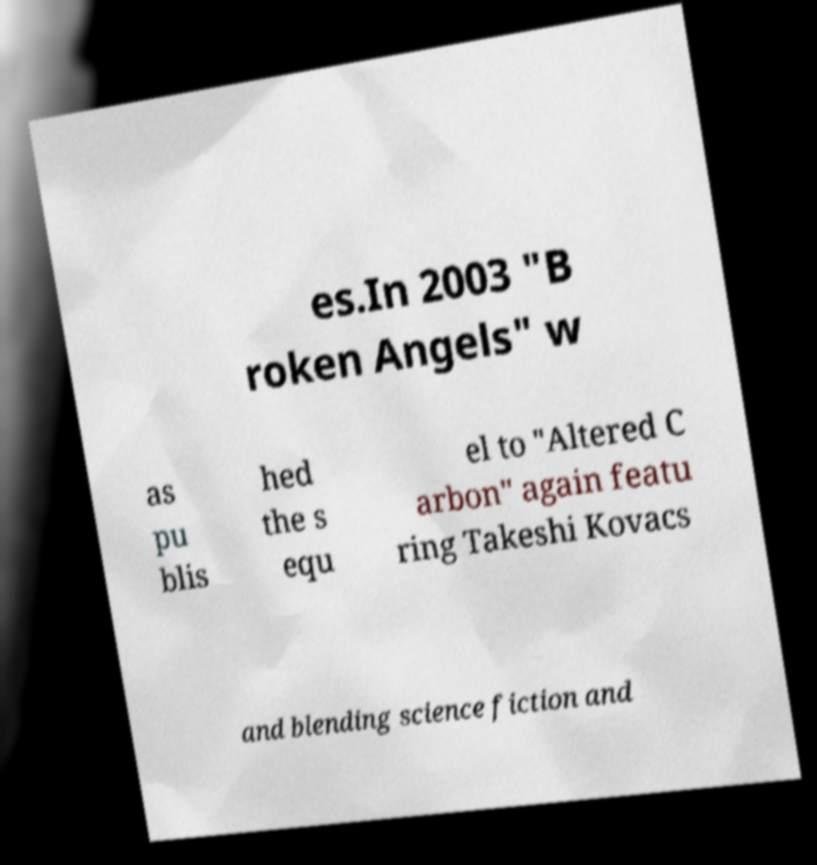Can you read and provide the text displayed in the image?This photo seems to have some interesting text. Can you extract and type it out for me? es.In 2003 "B roken Angels" w as pu blis hed the s equ el to "Altered C arbon" again featu ring Takeshi Kovacs and blending science fiction and 